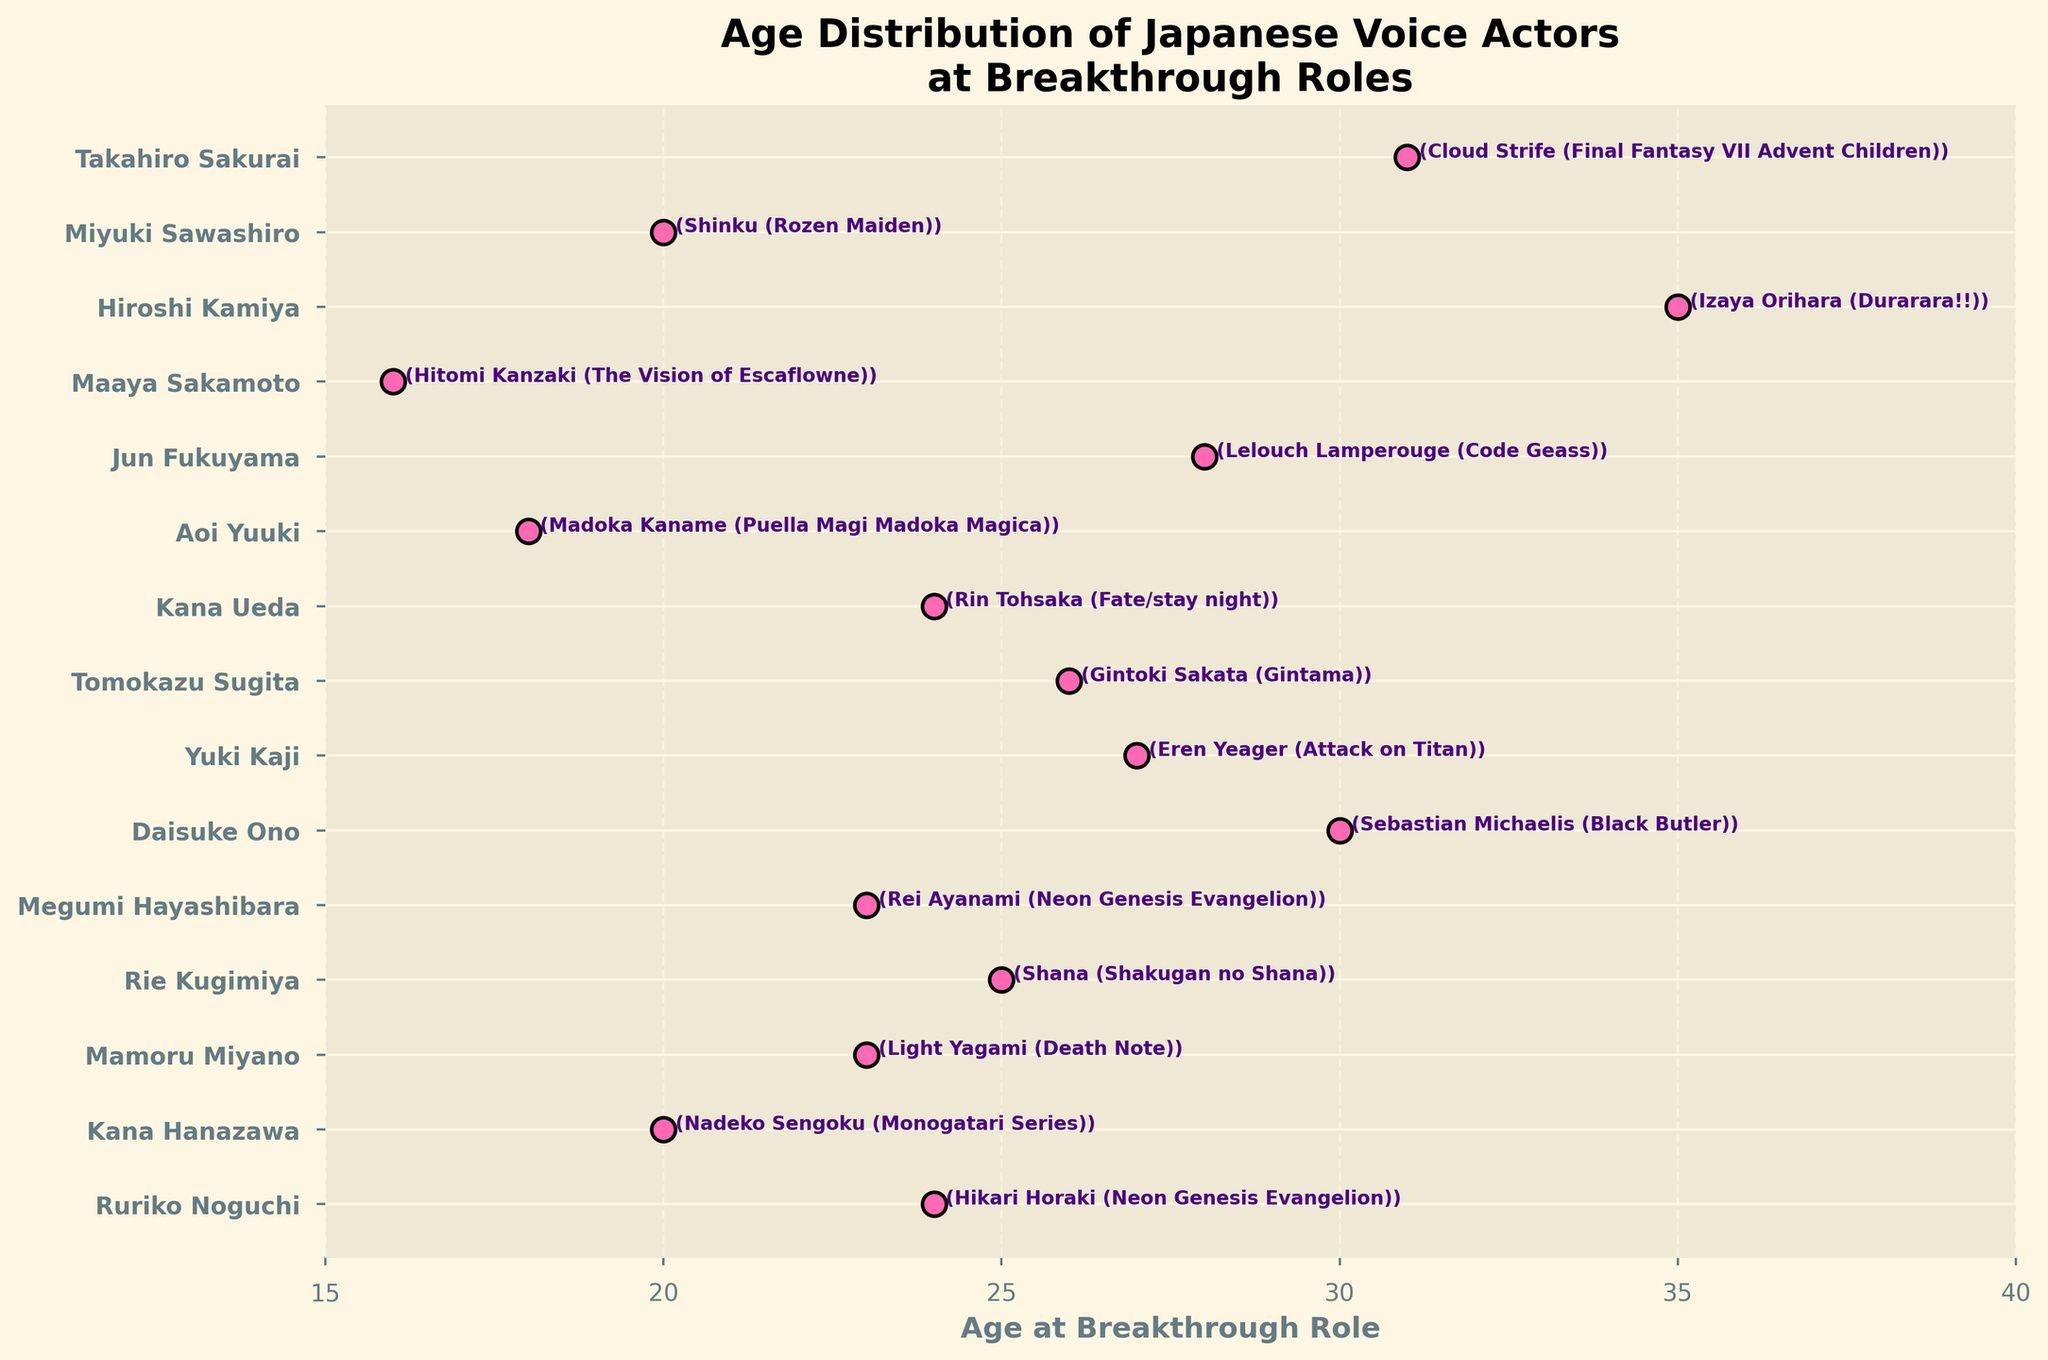What's the title of the figure? The title is usually displayed at the top of the figure. This one says "Age Distribution of Japanese Voice Actors\nat Breakthrough Roles".
Answer: Age Distribution of Japanese Voice Actors at Breakthrough Roles How old was Ruriko Noguchi at her breakthrough role? Locate the dot corresponding to Ruriko Noguchi, then look at the x-axis value it aligns with. It highlights 24 years old for "Hikari Horaki (Neon Genesis Evangelion)".
Answer: 24 Which voice actor was the youngest at their breakthrough role? Identify the dot with the lowest x-axis value. Maaya Sakamoto, with 16 years as "Hitomi Kanzaki (The Vision of Escaflowne)", is the youngest.
Answer: Maaya Sakamoto Who was older at their breakthrough role, Takahiro Sakurai or Hiroshi Kamiya? Compare the x-axis values for Takahiro Sakurai (31 years) and Hiroshi Kamiya (35 years). Hiroshi Kamiya was older.
Answer: Hiroshi Kamiya What is the average age of the voice actors at their breakthrough roles? Calculate the sum of all ages and divide by the number of voice actors. Sum (24+20+23+25+23+30+27+26+24+18+28+16+35+20+31) = 370. Then, divide 370 by 15 actors.
Answer: 24.67 How many voice actors had their breakthrough role in their 20s? Count dots that fall within the x-axis range from 20 to 29 years. These are Kana Hanazawa, Miyuki Sawashiro, Mamoru Miyano, Ruriko Noguchi, Megumi Hayashibara, Rie Kugimiya, Tomokazu Sugita, Yuki Kaji, Jun Fukuyama, and Kana Ueda, totaling 10.
Answer: 10 What is the range of ages observed in the figure? Find the difference between the oldest and youngest ages. The range is 35 (Hiroshi Kamiya) - 16 (Maaya Sakamoto).
Answer: 19 Which breakthrough role happened at age 30? Check the annotation for the dot at the x-axis value of 30. It indicates Daisuke Ono for "Sebastian Michaelis (Black Butler)".
Answer: Daisuke Ono, Sebastian Michaelis (Black Butler) Who had their breakthrough role at age 27 and what was the role? Look at the annotation for the dot at the x-axis value of 27. It refers to Yuki Kaji for "Eren Yeager (Attack on Titan)".
Answer: Yuki Kaji, Eren Yeager (Attack on Titan) What is the median age of the voice actors? Order all ages and find the middle value. Sorted ages: 16, 18, 20, 20, 23, 23, 24, 24, 25, 26, 27, 28, 30, 31, 35. The middle value (8th) is 24.
Answer: 24 